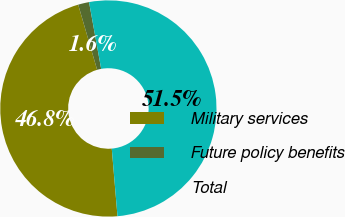<chart> <loc_0><loc_0><loc_500><loc_500><pie_chart><fcel>Military services<fcel>Future policy benefits<fcel>Total<nl><fcel>46.84%<fcel>1.64%<fcel>51.52%<nl></chart> 